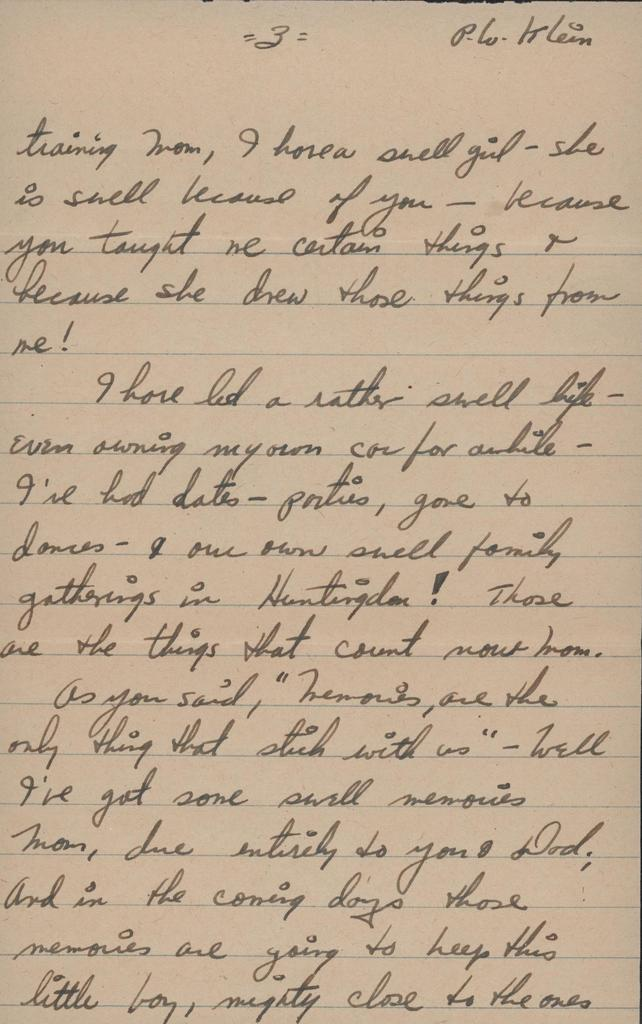<image>
Create a compact narrative representing the image presented. A handwritten letter from somebody to their mom talking about their life. 